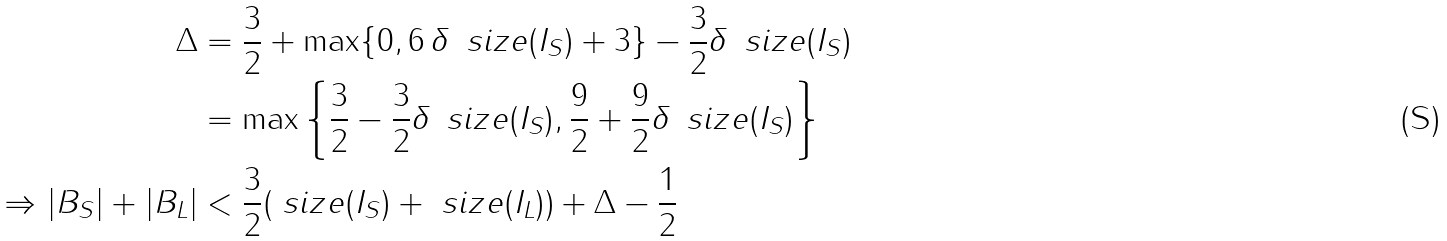Convert formula to latex. <formula><loc_0><loc_0><loc_500><loc_500>\Delta & = \frac { 3 } { 2 } + \max \{ 0 , 6 \, \delta \, \ s i z e ( I _ { S } ) + 3 \} - \frac { 3 } { 2 } \delta \, \ s i z e ( I _ { S } ) \\ & = \max \left \{ \frac { 3 } { 2 } - \frac { 3 } { 2 } \delta \, \ s i z e ( I _ { S } ) , \frac { 9 } { 2 } + \frac { 9 } { 2 } \delta \, \ s i z e ( I _ { S } ) \right \} \\ \Rightarrow | B _ { S } | + | B _ { L } | & < \frac { 3 } { 2 } ( \ s i z e ( I _ { S } ) + \ s i z e ( I _ { L } ) ) + \Delta - \frac { 1 } { 2 }</formula> 